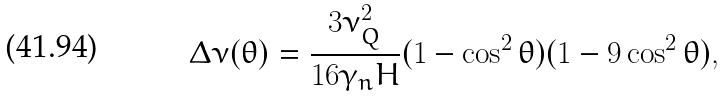<formula> <loc_0><loc_0><loc_500><loc_500>\Delta \nu ( \theta ) = \frac { 3 \nu _ { Q } ^ { 2 } } { 1 6 \gamma _ { n } H } ( 1 - \cos ^ { 2 } \theta ) ( 1 - 9 \cos ^ { 2 } \theta ) ,</formula> 